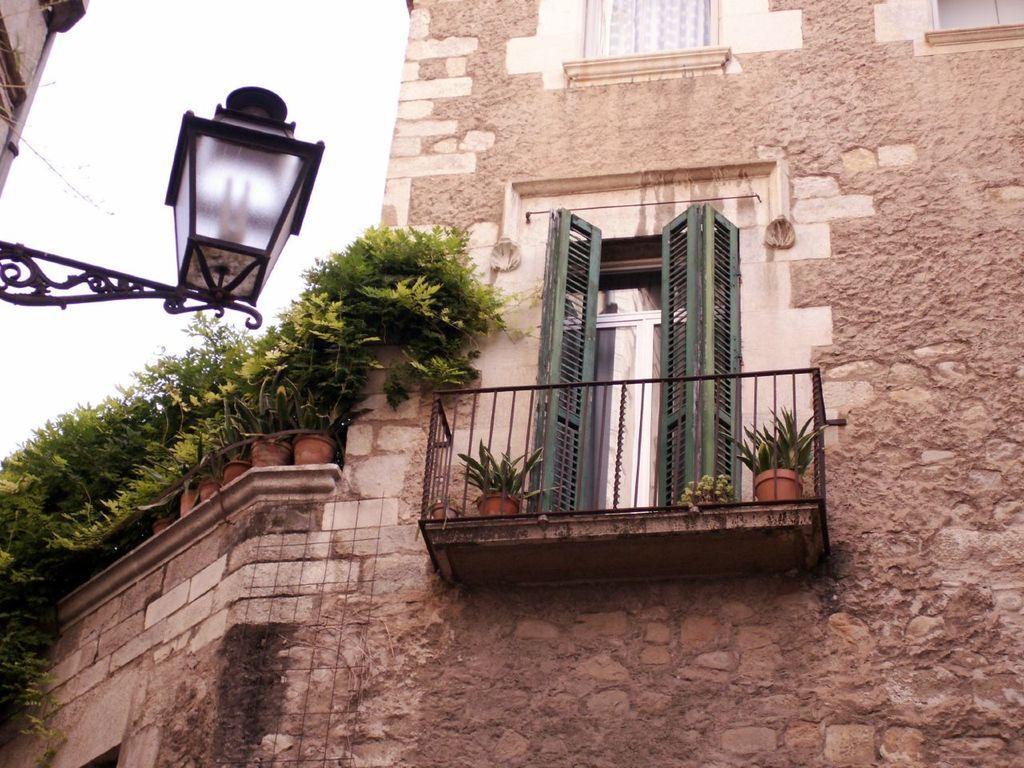Can you describe this image briefly? In this image, we can see a building. There is a door in between two plants. There is a light and some plants on the left side of the image. There is a sky in the top left of the image. 